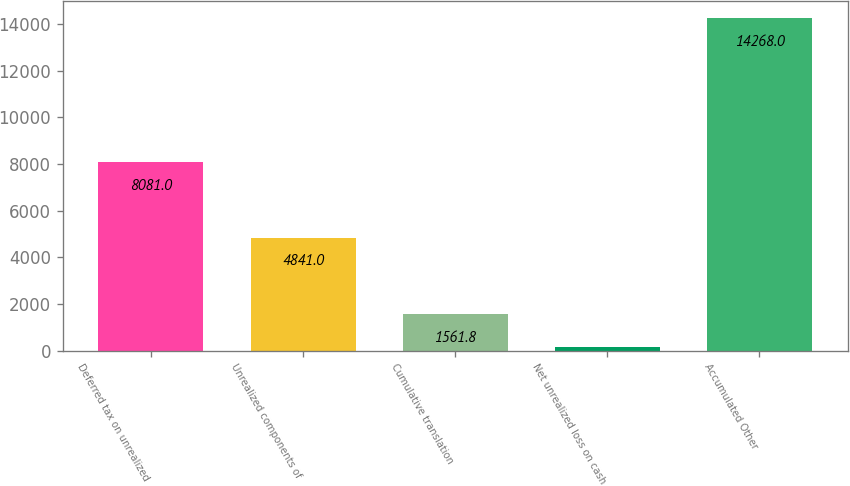Convert chart. <chart><loc_0><loc_0><loc_500><loc_500><bar_chart><fcel>Deferred tax on unrealized<fcel>Unrealized components of<fcel>Cumulative translation<fcel>Net unrealized loss on cash<fcel>Accumulated Other<nl><fcel>8081<fcel>4841<fcel>1561.8<fcel>150<fcel>14268<nl></chart> 